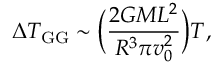Convert formula to latex. <formula><loc_0><loc_0><loc_500><loc_500>\Delta T _ { G G } \sim \left ( \frac { 2 G M L ^ { 2 } } { R ^ { 3 } \pi v _ { 0 } ^ { 2 } } \right ) T ,</formula> 